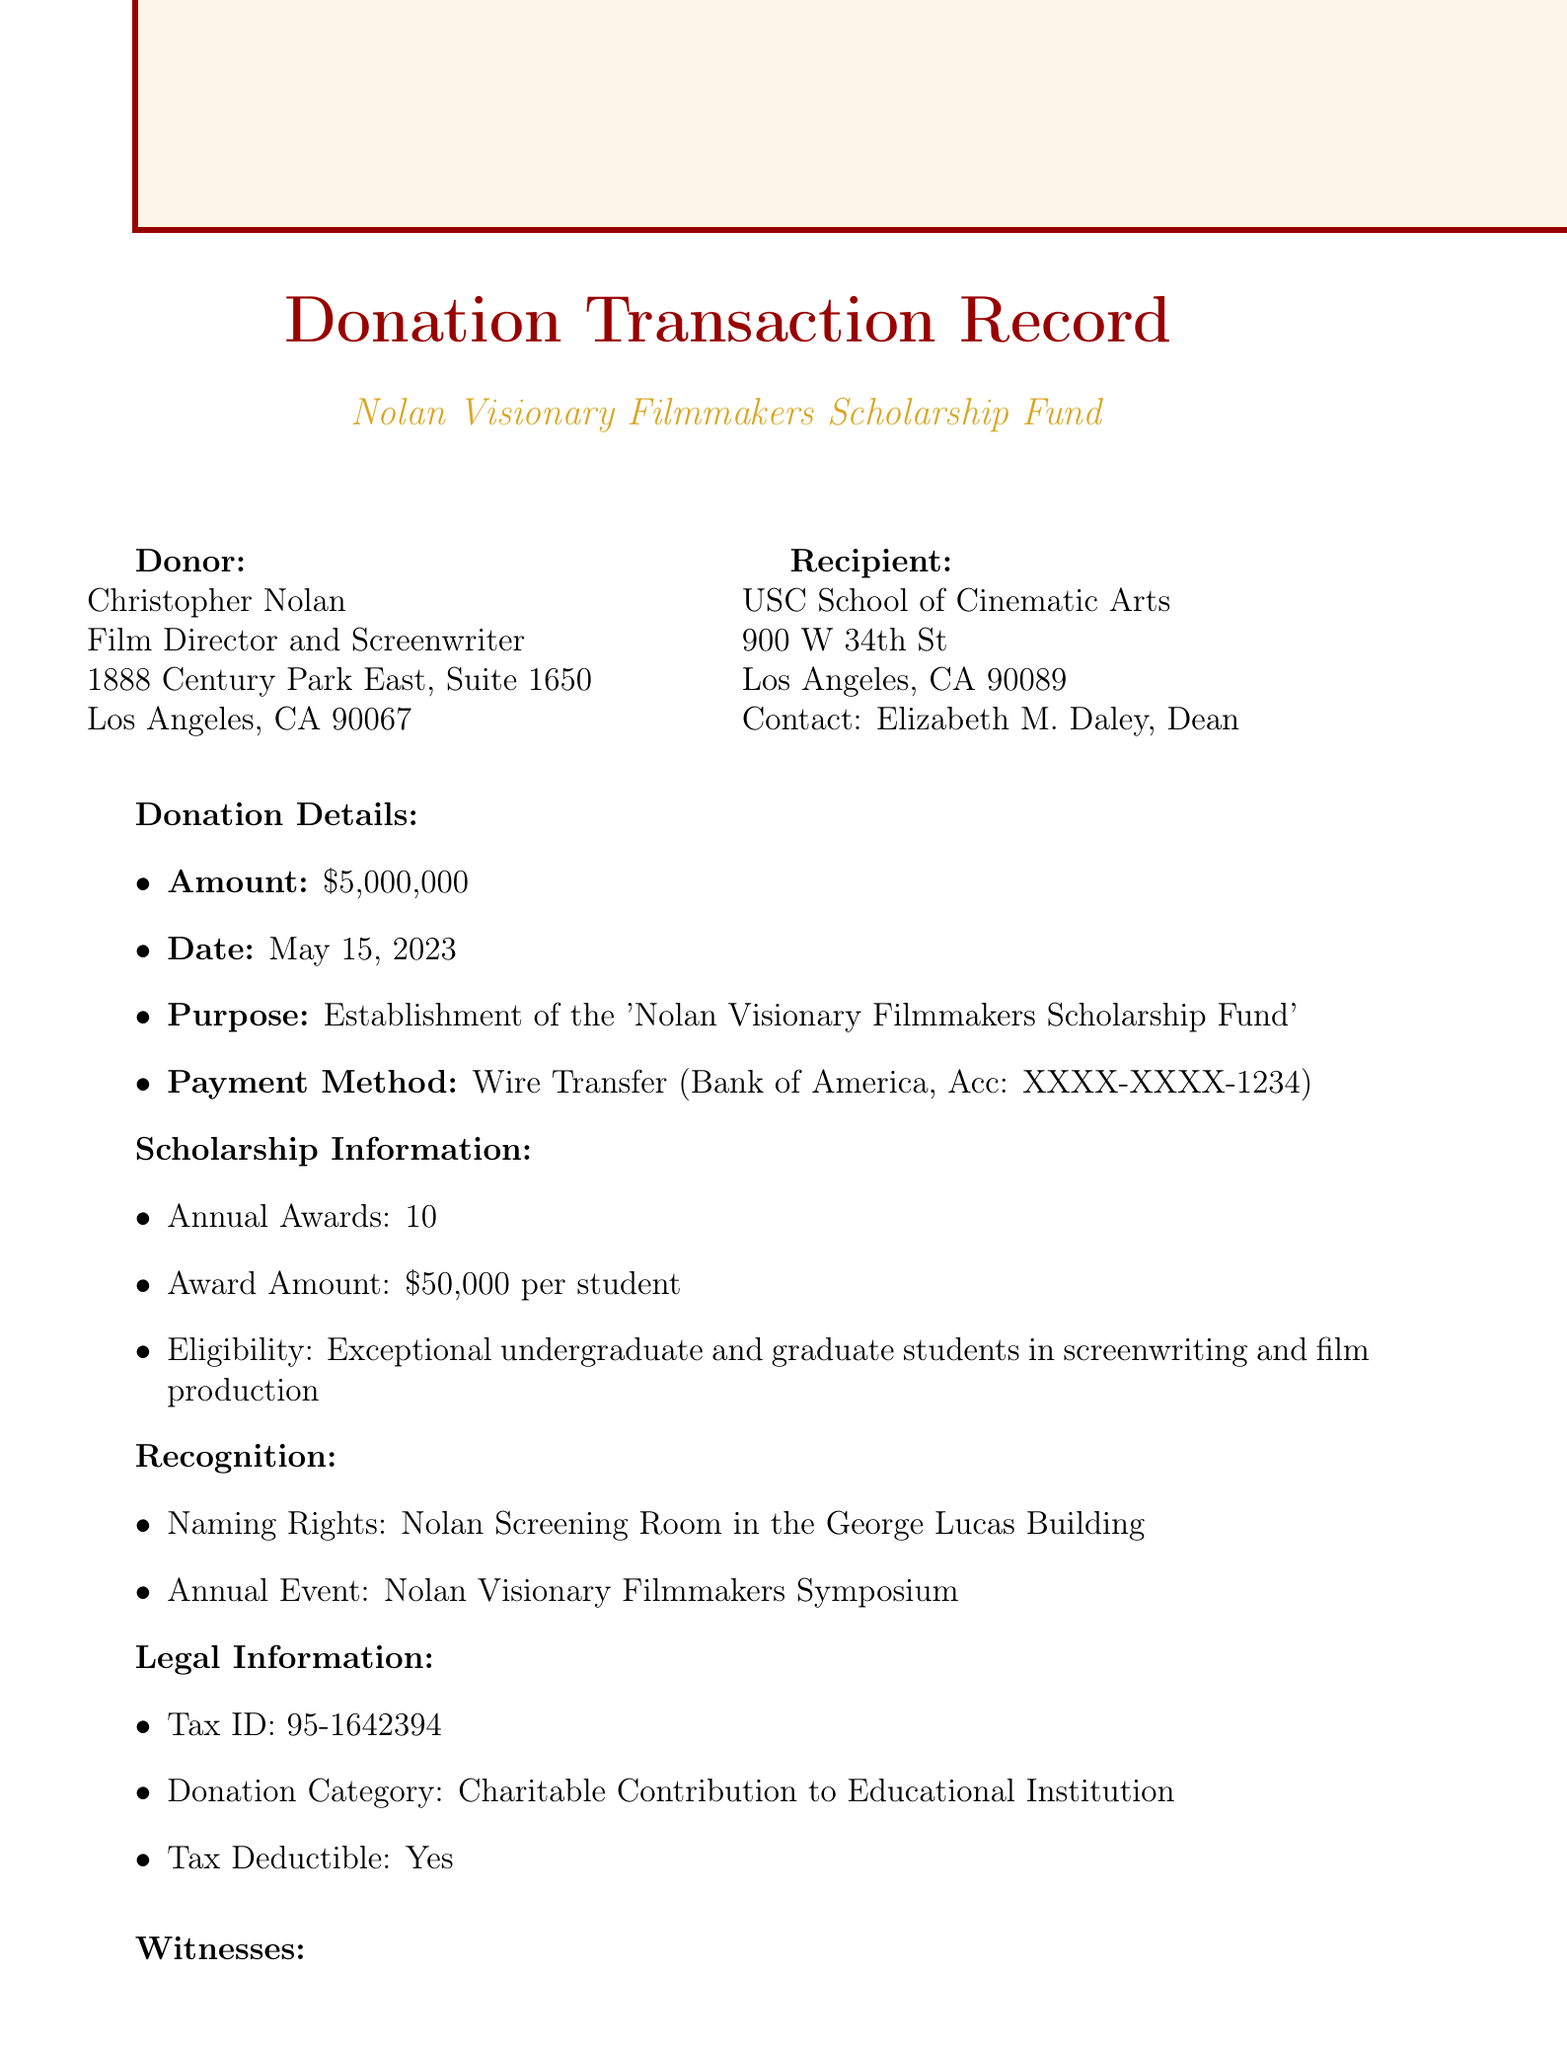What is the donor's name? The donor's name, as stated in the document, is Christopher Nolan.
Answer: Christopher Nolan What is the amount of the donation? The document specifies that the donation amount is five million dollars, denoted as $5,000,000.
Answer: $5,000,000 When was the donation made? The document indicates that the donation was made on May 15, 2023.
Answer: May 15, 2023 How many annual awards will be given through the scholarship? The number of annual awards specified in the document is ten.
Answer: 10 What is the purpose of the donation? The document states that the purpose of the donation is to establish the 'Nolan Visionary Filmmakers Scholarship Fund'.
Answer: Establishment of the 'Nolan Visionary Filmmakers Scholarship Fund' Who is the contact person at the recipient institution? The document lists Elizabeth M. Daley as the contact person for the USC School of Cinematic Arts.
Answer: Elizabeth M. Daley What are the naming rights associated with the donation? The naming rights mentioned in the document refer to the "Nolan Screening Room in the George Lucas Building".
Answer: Nolan Screening Room in the George Lucas Building Who are the witnesses for the donation? The witnesses listed in the document are Steven Spielberg and Emma Thomas.
Answer: Steven Spielberg and Emma Thomas What is the tax category for the donation? The document categorizes the donation as a charitable contribution to an educational institution.
Answer: Charitable Contribution to Educational Institution 